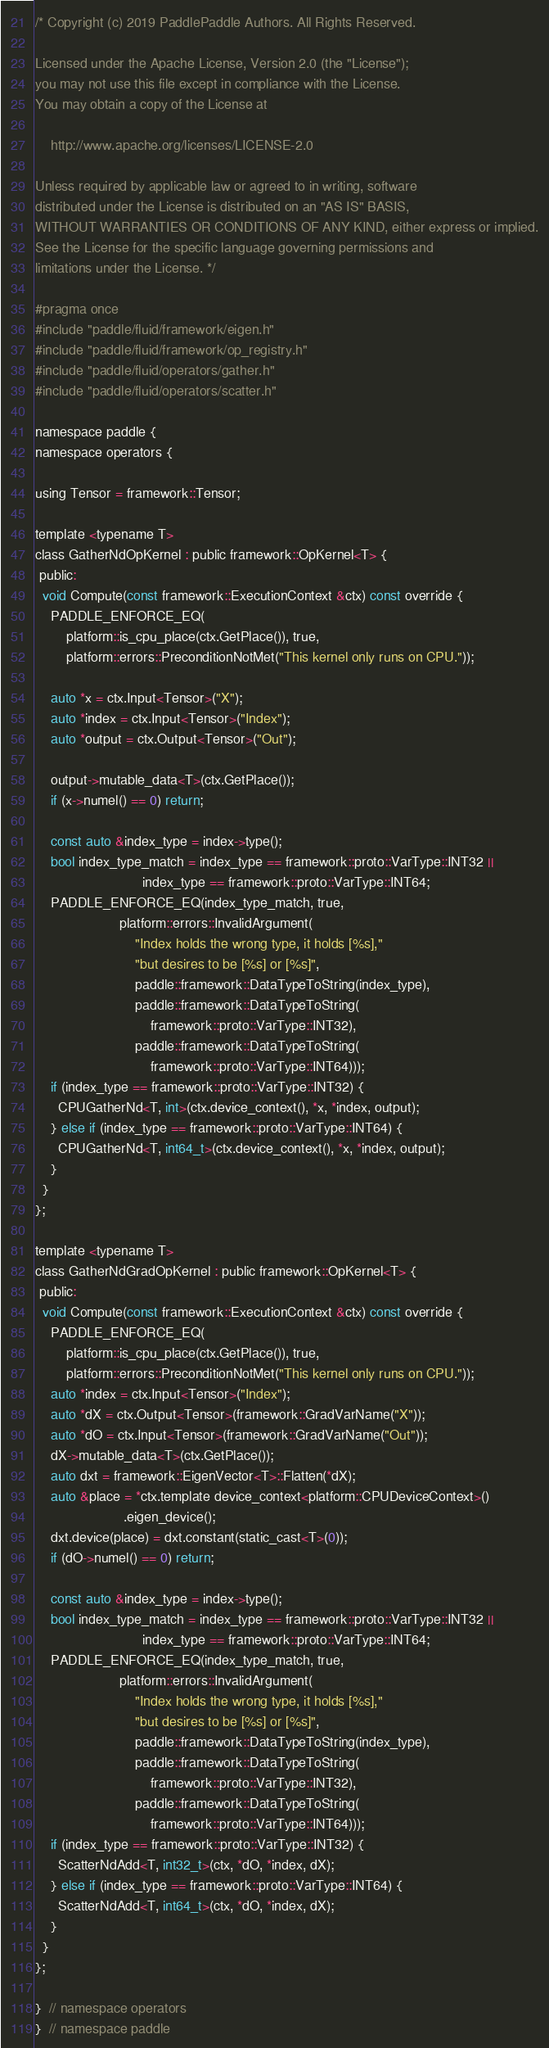Convert code to text. <code><loc_0><loc_0><loc_500><loc_500><_C_>/* Copyright (c) 2019 PaddlePaddle Authors. All Rights Reserved.

Licensed under the Apache License, Version 2.0 (the "License");
you may not use this file except in compliance with the License.
You may obtain a copy of the License at

    http://www.apache.org/licenses/LICENSE-2.0

Unless required by applicable law or agreed to in writing, software
distributed under the License is distributed on an "AS IS" BASIS,
WITHOUT WARRANTIES OR CONDITIONS OF ANY KIND, either express or implied.
See the License for the specific language governing permissions and
limitations under the License. */

#pragma once
#include "paddle/fluid/framework/eigen.h"
#include "paddle/fluid/framework/op_registry.h"
#include "paddle/fluid/operators/gather.h"
#include "paddle/fluid/operators/scatter.h"

namespace paddle {
namespace operators {

using Tensor = framework::Tensor;

template <typename T>
class GatherNdOpKernel : public framework::OpKernel<T> {
 public:
  void Compute(const framework::ExecutionContext &ctx) const override {
    PADDLE_ENFORCE_EQ(
        platform::is_cpu_place(ctx.GetPlace()), true,
        platform::errors::PreconditionNotMet("This kernel only runs on CPU."));

    auto *x = ctx.Input<Tensor>("X");
    auto *index = ctx.Input<Tensor>("Index");
    auto *output = ctx.Output<Tensor>("Out");

    output->mutable_data<T>(ctx.GetPlace());
    if (x->numel() == 0) return;

    const auto &index_type = index->type();
    bool index_type_match = index_type == framework::proto::VarType::INT32 ||
                            index_type == framework::proto::VarType::INT64;
    PADDLE_ENFORCE_EQ(index_type_match, true,
                      platform::errors::InvalidArgument(
                          "Index holds the wrong type, it holds [%s],"
                          "but desires to be [%s] or [%s]",
                          paddle::framework::DataTypeToString(index_type),
                          paddle::framework::DataTypeToString(
                              framework::proto::VarType::INT32),
                          paddle::framework::DataTypeToString(
                              framework::proto::VarType::INT64)));
    if (index_type == framework::proto::VarType::INT32) {
      CPUGatherNd<T, int>(ctx.device_context(), *x, *index, output);
    } else if (index_type == framework::proto::VarType::INT64) {
      CPUGatherNd<T, int64_t>(ctx.device_context(), *x, *index, output);
    }
  }
};

template <typename T>
class GatherNdGradOpKernel : public framework::OpKernel<T> {
 public:
  void Compute(const framework::ExecutionContext &ctx) const override {
    PADDLE_ENFORCE_EQ(
        platform::is_cpu_place(ctx.GetPlace()), true,
        platform::errors::PreconditionNotMet("This kernel only runs on CPU."));
    auto *index = ctx.Input<Tensor>("Index");
    auto *dX = ctx.Output<Tensor>(framework::GradVarName("X"));
    auto *dO = ctx.Input<Tensor>(framework::GradVarName("Out"));
    dX->mutable_data<T>(ctx.GetPlace());
    auto dxt = framework::EigenVector<T>::Flatten(*dX);
    auto &place = *ctx.template device_context<platform::CPUDeviceContext>()
                       .eigen_device();
    dxt.device(place) = dxt.constant(static_cast<T>(0));
    if (dO->numel() == 0) return;

    const auto &index_type = index->type();
    bool index_type_match = index_type == framework::proto::VarType::INT32 ||
                            index_type == framework::proto::VarType::INT64;
    PADDLE_ENFORCE_EQ(index_type_match, true,
                      platform::errors::InvalidArgument(
                          "Index holds the wrong type, it holds [%s],"
                          "but desires to be [%s] or [%s]",
                          paddle::framework::DataTypeToString(index_type),
                          paddle::framework::DataTypeToString(
                              framework::proto::VarType::INT32),
                          paddle::framework::DataTypeToString(
                              framework::proto::VarType::INT64)));
    if (index_type == framework::proto::VarType::INT32) {
      ScatterNdAdd<T, int32_t>(ctx, *dO, *index, dX);
    } else if (index_type == framework::proto::VarType::INT64) {
      ScatterNdAdd<T, int64_t>(ctx, *dO, *index, dX);
    }
  }
};

}  // namespace operators
}  // namespace paddle
</code> 